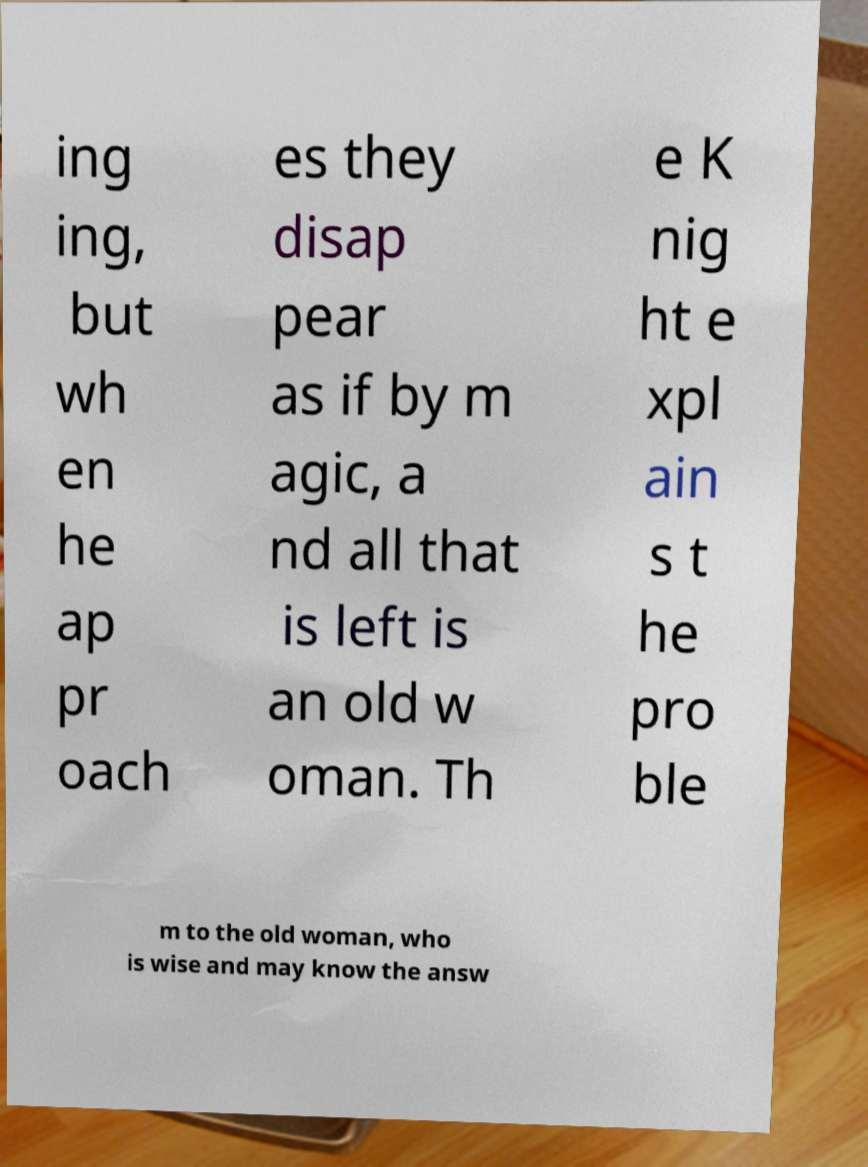Could you extract and type out the text from this image? ing ing, but wh en he ap pr oach es they disap pear as if by m agic, a nd all that is left is an old w oman. Th e K nig ht e xpl ain s t he pro ble m to the old woman, who is wise and may know the answ 